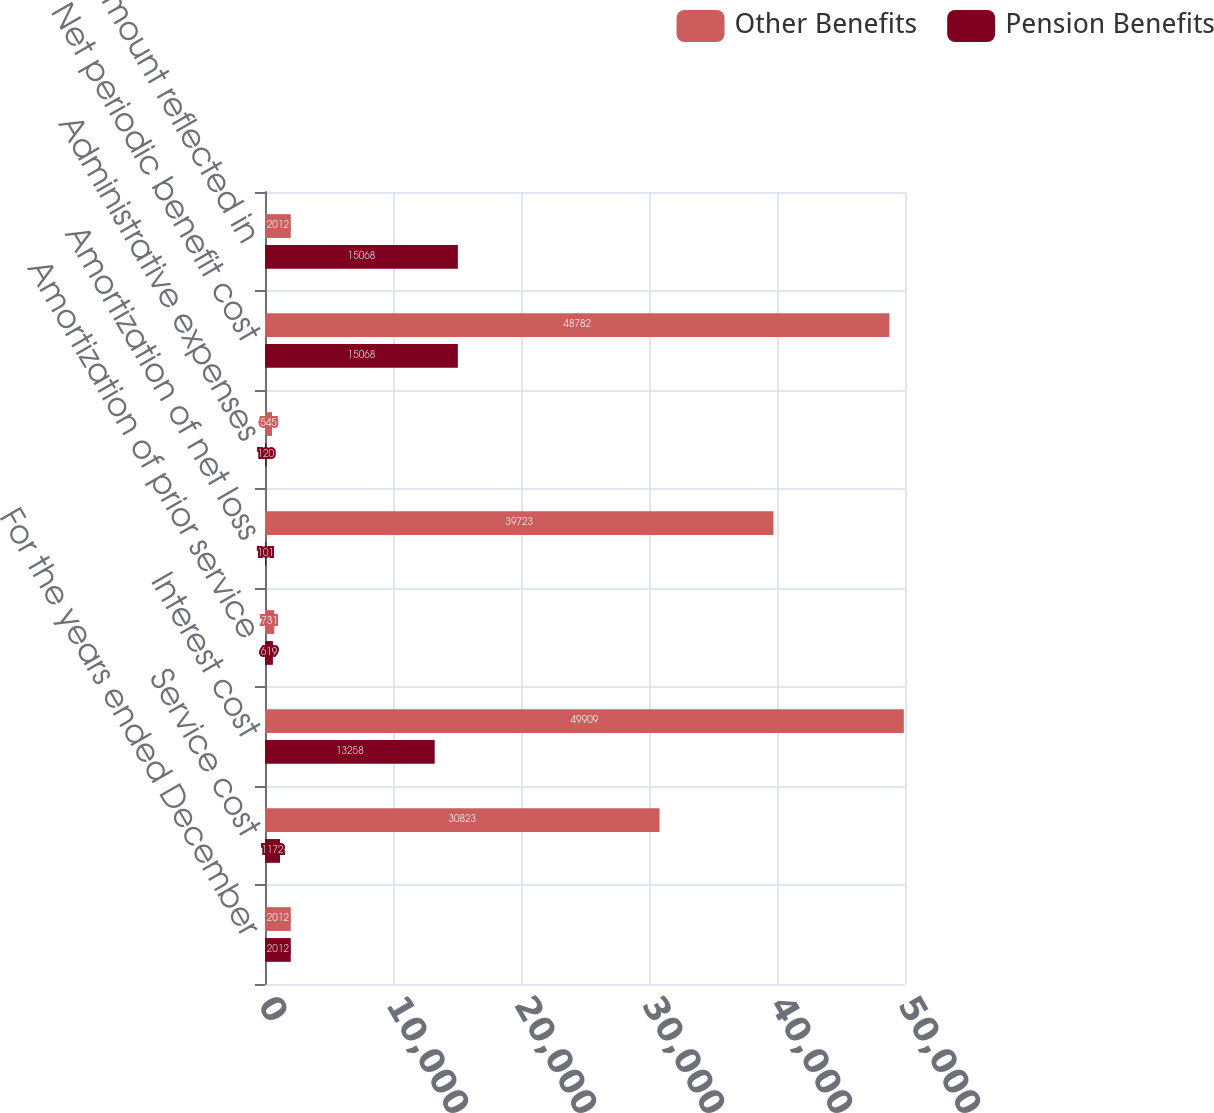Convert chart. <chart><loc_0><loc_0><loc_500><loc_500><stacked_bar_chart><ecel><fcel>For the years ended December<fcel>Service cost<fcel>Interest cost<fcel>Amortization of prior service<fcel>Amortization of net loss<fcel>Administrative expenses<fcel>Net periodic benefit cost<fcel>Total amount reflected in<nl><fcel>Other Benefits<fcel>2012<fcel>30823<fcel>49909<fcel>731<fcel>39723<fcel>545<fcel>48782<fcel>2012<nl><fcel>Pension Benefits<fcel>2012<fcel>1172<fcel>13258<fcel>619<fcel>101<fcel>120<fcel>15068<fcel>15068<nl></chart> 